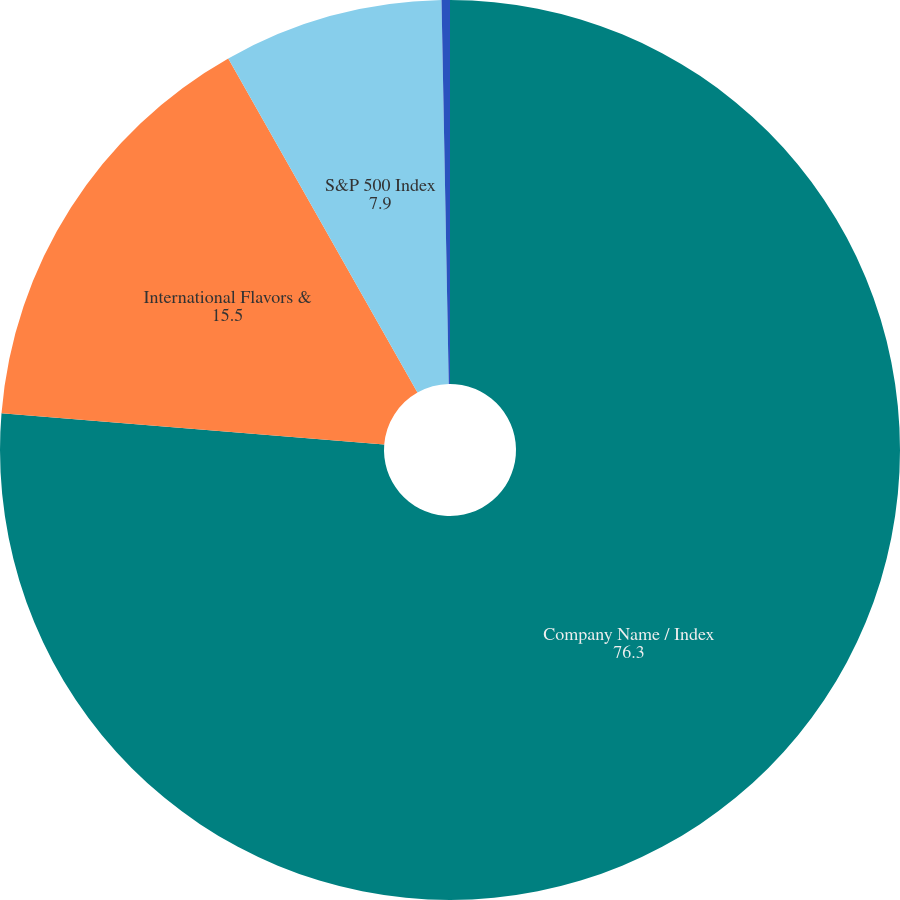Convert chart to OTSL. <chart><loc_0><loc_0><loc_500><loc_500><pie_chart><fcel>Company Name / Index<fcel>International Flavors &<fcel>S&P 500 Index<fcel>Peer Group<nl><fcel>76.3%<fcel>15.5%<fcel>7.9%<fcel>0.3%<nl></chart> 